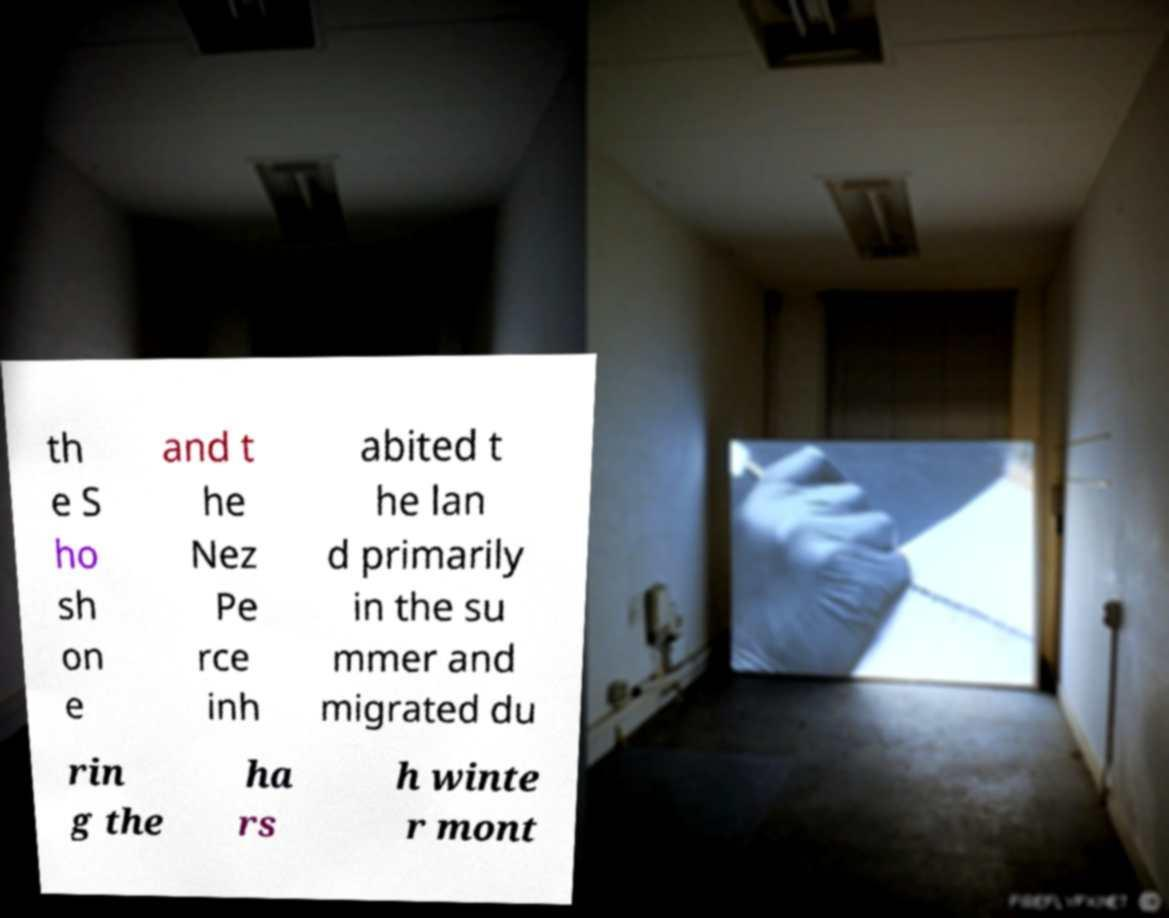Could you extract and type out the text from this image? th e S ho sh on e and t he Nez Pe rce inh abited t he lan d primarily in the su mmer and migrated du rin g the ha rs h winte r mont 